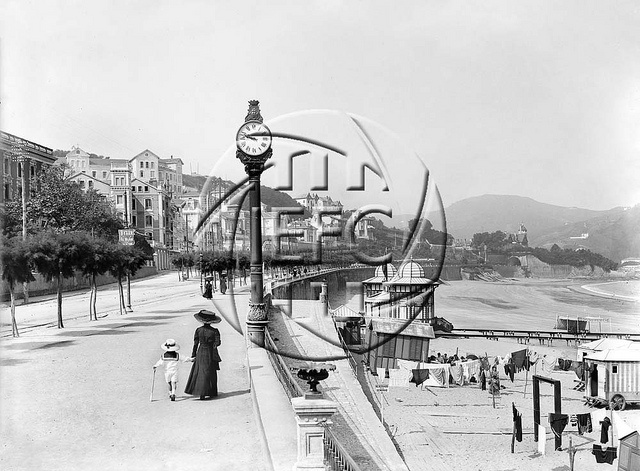Describe the objects in this image and their specific colors. I can see people in white, black, gray, lightgray, and darkgray tones, clock in white, lightgray, darkgray, gray, and black tones, people in white, lightgray, darkgray, black, and gray tones, people in black, gray, darkgray, and white tones, and people in black, gray, darkgray, and white tones in this image. 